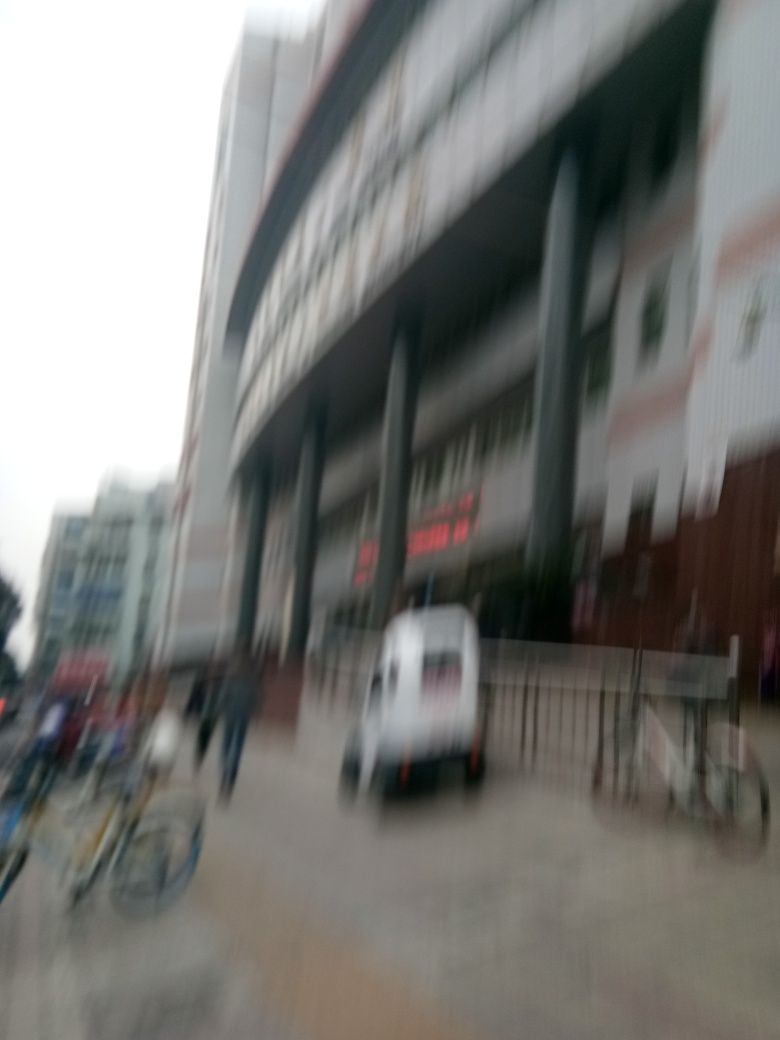Are there any quality issues with this image? Yes, the image is blurry which affects the sharpness and clarity. This blurriness could be due to camera motion during capture or focus issues. It makes it difficult to discern fine details and may compromise the usability of the image for certain purposes. 